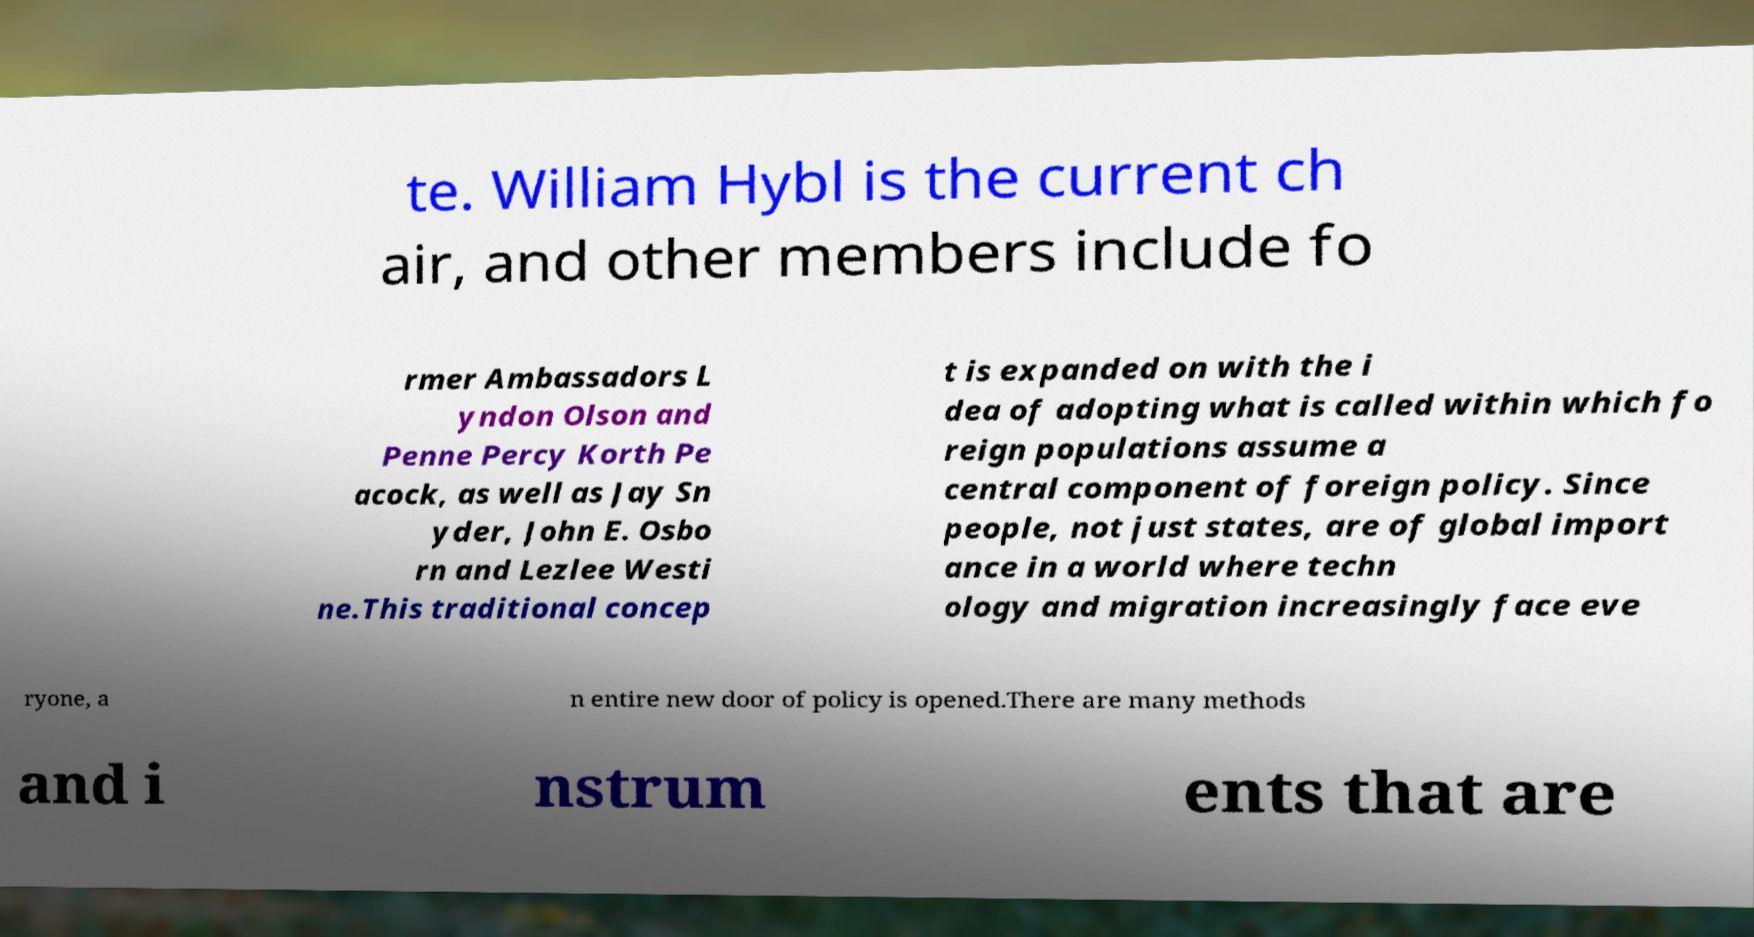What messages or text are displayed in this image? I need them in a readable, typed format. te. William Hybl is the current ch air, and other members include fo rmer Ambassadors L yndon Olson and Penne Percy Korth Pe acock, as well as Jay Sn yder, John E. Osbo rn and Lezlee Westi ne.This traditional concep t is expanded on with the i dea of adopting what is called within which fo reign populations assume a central component of foreign policy. Since people, not just states, are of global import ance in a world where techn ology and migration increasingly face eve ryone, a n entire new door of policy is opened.There are many methods and i nstrum ents that are 